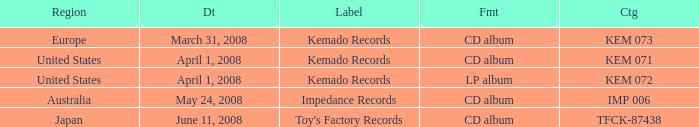Which Format has a Label of toy's factory records? CD album. 